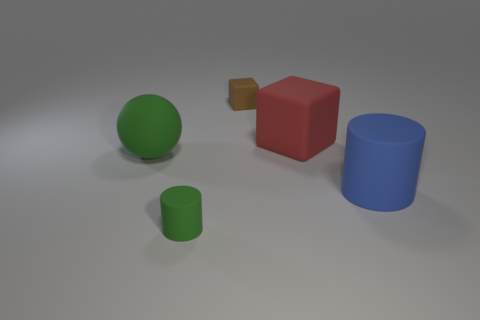Add 3 big blue balls. How many objects exist? 8 Subtract 0 blue spheres. How many objects are left? 5 Subtract all cylinders. How many objects are left? 3 Subtract all cyan cubes. Subtract all blue cylinders. How many cubes are left? 2 Subtract all cyan blocks. How many cyan spheres are left? 0 Subtract all large green rubber spheres. Subtract all big red objects. How many objects are left? 3 Add 2 big matte cylinders. How many big matte cylinders are left? 3 Add 2 small purple matte cubes. How many small purple matte cubes exist? 2 